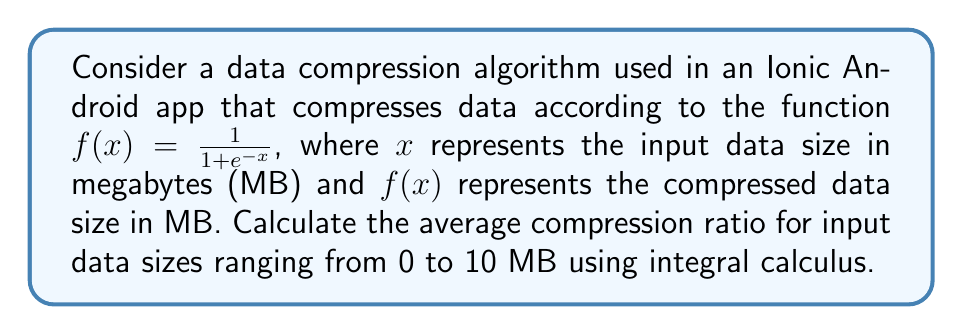Teach me how to tackle this problem. To solve this problem, we'll follow these steps:

1) The compression ratio at any point is given by $\frac{x}{f(x)}$.

2) To find the average compression ratio over the range [0, 10], we need to integrate the compression ratio function and divide by the range:

   $$\text{Average Ratio} = \frac{1}{10} \int_0^{10} \frac{x}{f(x)} dx$$

3) Substituting $f(x) = \frac{1}{1 + e^{-x}}$:

   $$\text{Average Ratio} = \frac{1}{10} \int_0^{10} x(1 + e^{-x}) dx$$

4) Expand the integral:

   $$\text{Average Ratio} = \frac{1}{10} \int_0^{10} (x + xe^{-x}) dx$$

5) Integrate each term:
   
   For $\int x dx = \frac{x^2}{2}$
   
   For $\int xe^{-x} dx$, use integration by parts:
   $u = x$, $du = dx$
   $dv = e^{-x} dx$, $v = -e^{-x}$
   
   $\int xe^{-x} dx = -xe^{-x} - \int -e^{-x} dx = -xe^{-x} - e^{-x} + C$

6) Apply the limits:

   $$\text{Average Ratio} = \frac{1}{10} \left[\frac{x^2}{2} - xe^{-x} - e^{-x}\right]_0^{10}$$

7) Evaluate:

   $$\text{Average Ratio} = \frac{1}{10} \left[\frac{100}{2} - 10e^{-10} - e^{-10} - (0 - 0 - 1)\right]$$

8) Simplify:

   $$\text{Average Ratio} = \frac{1}{10} \left[50 - 10e^{-10} - e^{-10} + 1\right]$$

9) Calculate the final value:

   $$\text{Average Ratio} \approx 5.1$$
Answer: 5.1 